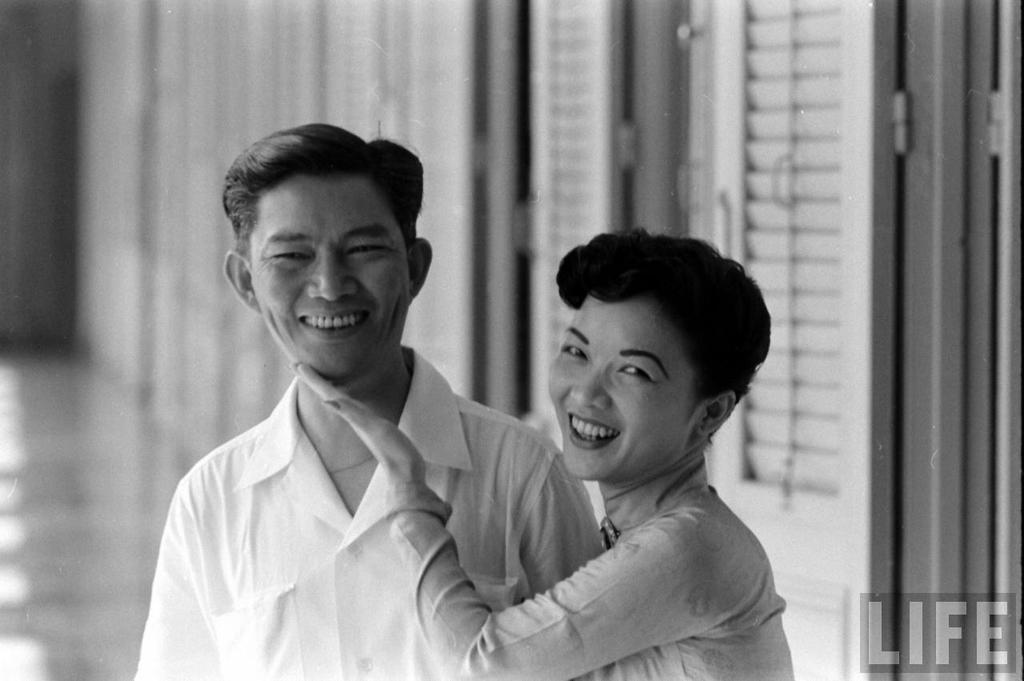What is the color scheme of the image? The image is black and white. Who is present in the image? There is a girl and a man in the image. What is the girl doing in the image? The girl is touching the cheeks of the man beside her. What can be seen in the background of the image? There are doors in the background of the image. Can you see a jar in the image? There is no jar present in the image. 